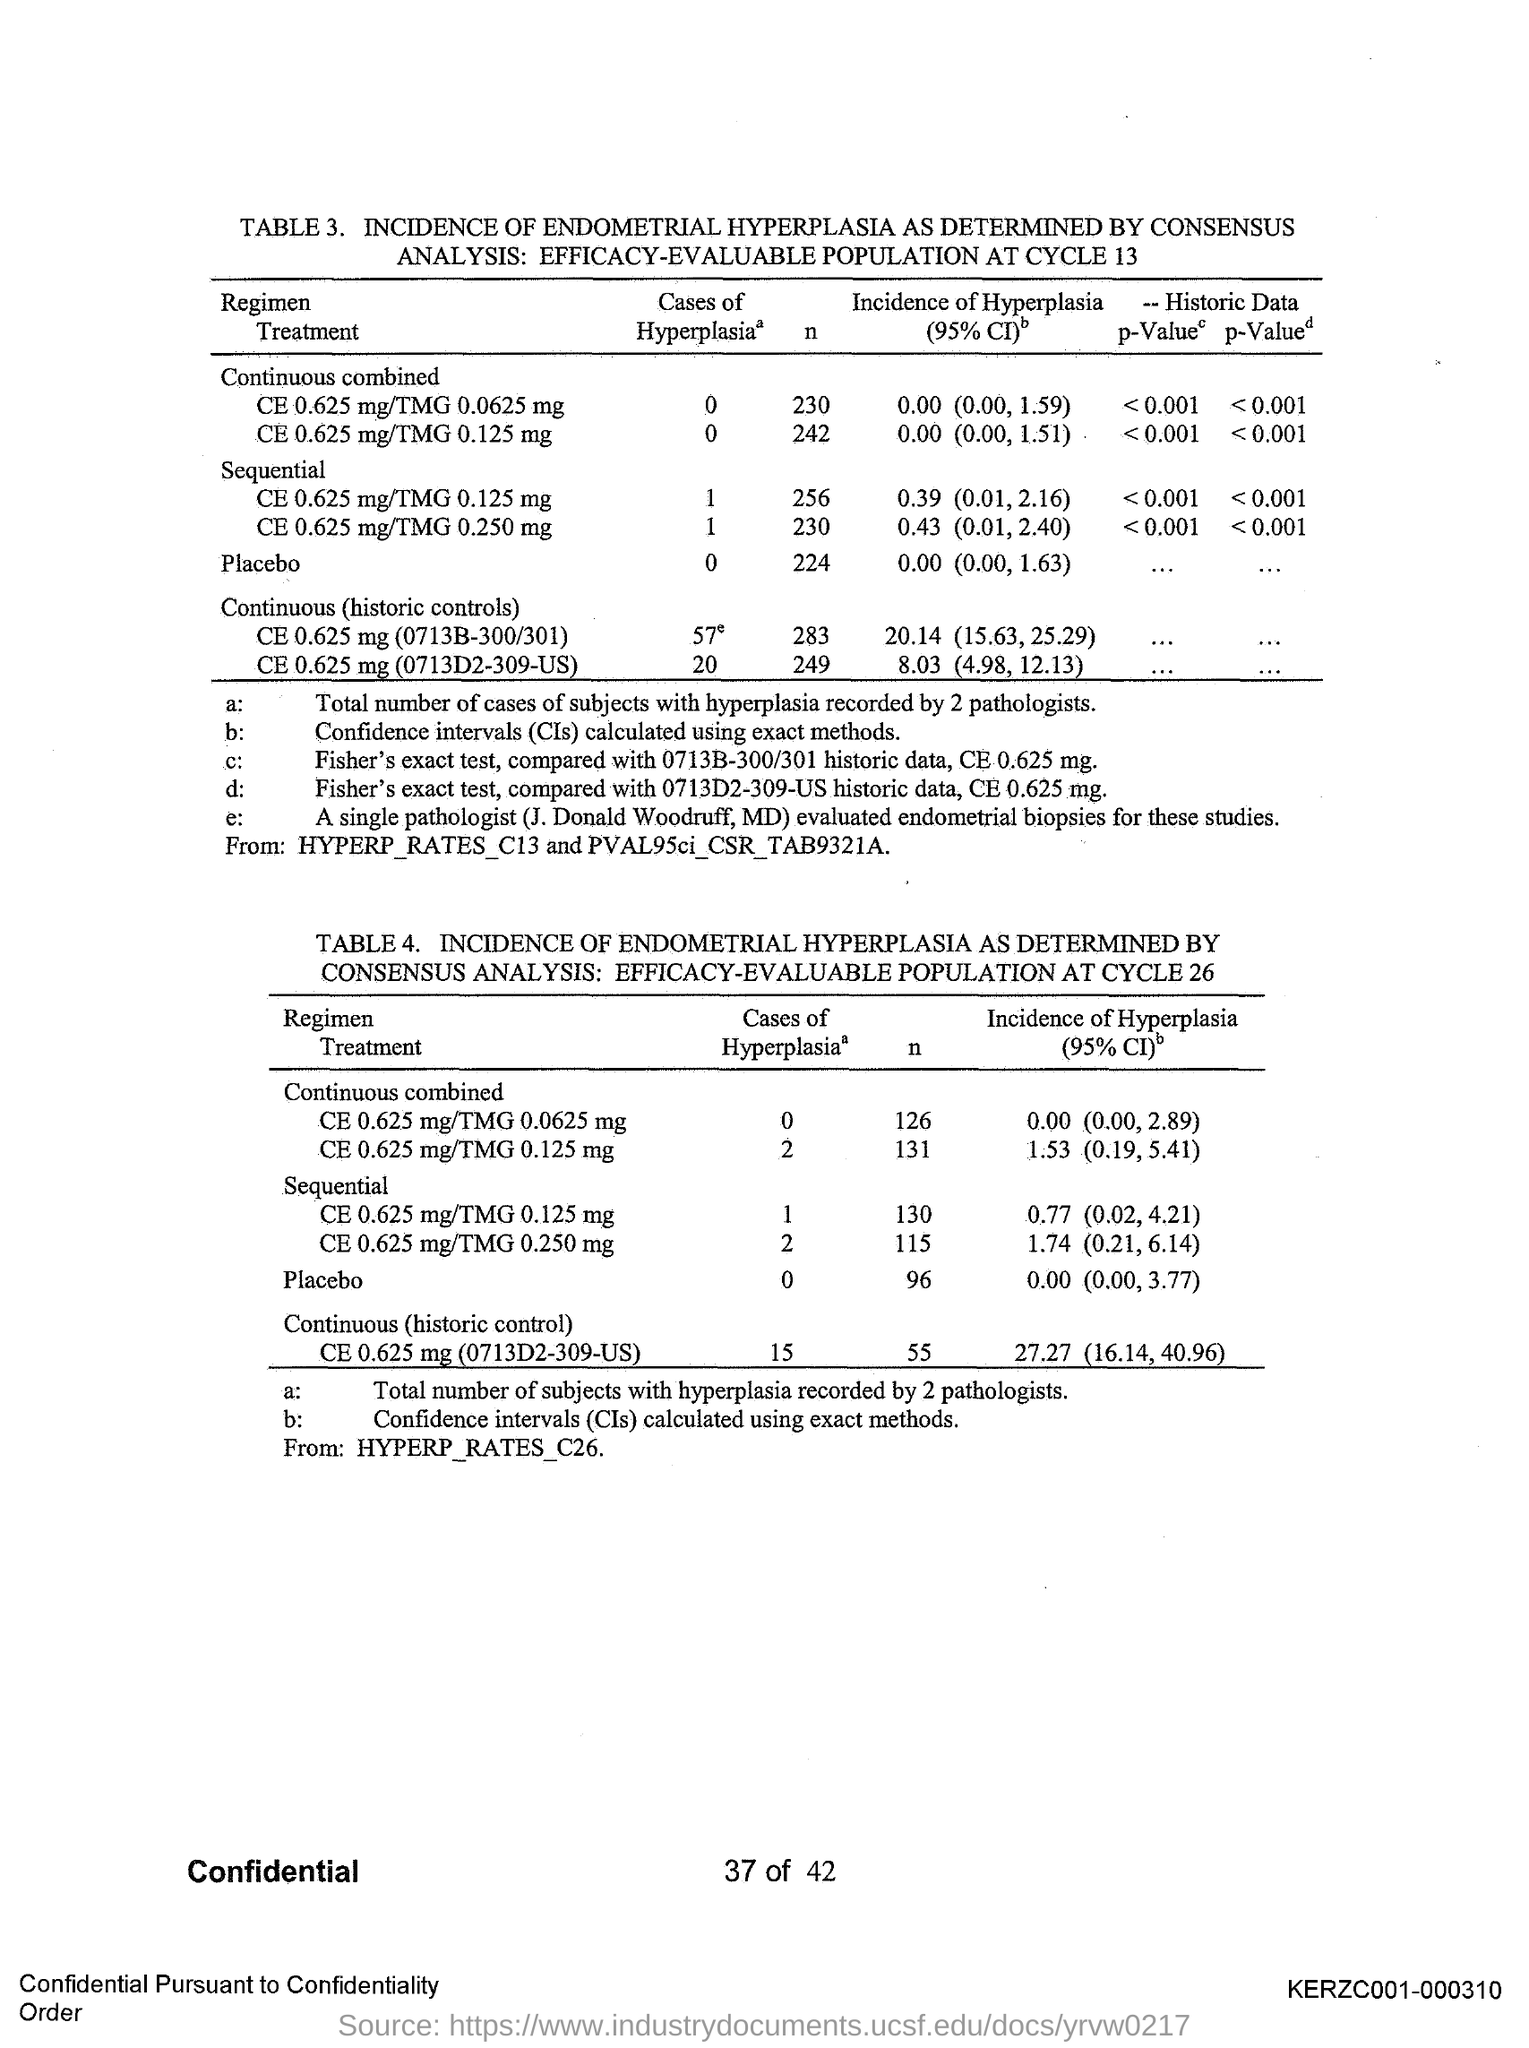Draw attention to some important aspects in this diagram. The second table has the number 4.. Confidence intervals are a statistical method used to estimate a population parameter with a certain level of confidence. The first table has number 3. 